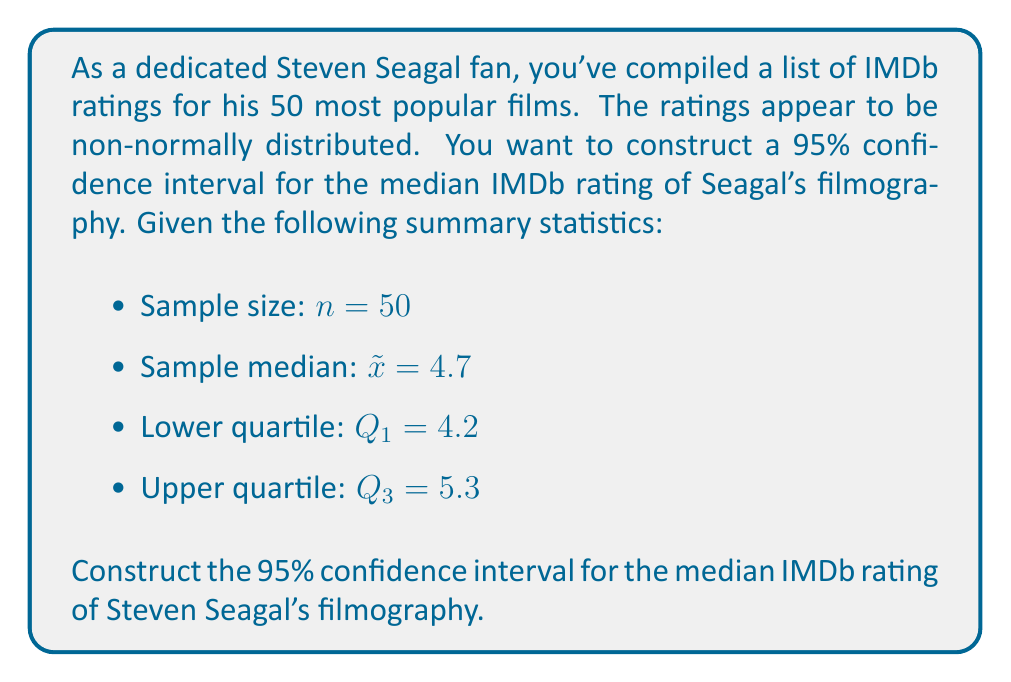Solve this math problem. To construct a confidence interval for the median when the data is non-normally distributed, we can use the following method:

1. Calculate the standard error of the median:
   $SE_{median} = \frac{IQR}{1.349\sqrt{n}}$, where IQR is the interquartile range.

2. Calculate the IQR:
   $IQR = Q_3 - Q_1 = 5.3 - 4.2 = 1.1$

3. Calculate the standard error:
   $SE_{median} = \frac{1.1}{1.349\sqrt{50}} \approx 0.1156$

4. For a 95% confidence interval, use the z-score of 1.96 (from the standard normal distribution).

5. Calculate the margin of error:
   $ME = 1.96 \times SE_{median} = 1.96 \times 0.1156 \approx 0.2266$

6. Construct the confidence interval:
   Lower bound: $\tilde{x} - ME = 4.7 - 0.2266 \approx 4.4734$
   Upper bound: $\tilde{x} + ME = 4.7 + 0.2266 \approx 4.9266$

Therefore, the 95% confidence interval for the median IMDb rating of Steven Seagal's filmography is approximately (4.47, 4.93).
Answer: (4.47, 4.93) 